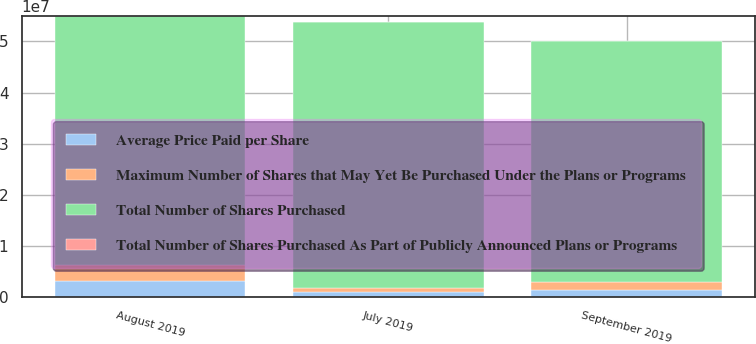<chart> <loc_0><loc_0><loc_500><loc_500><stacked_bar_chart><ecel><fcel>July 2019<fcel>August 2019<fcel>September 2019<nl><fcel>Average Price Paid per Share<fcel>971064<fcel>3.15705e+06<fcel>1.45965e+06<nl><fcel>Total Number of Shares Purchased As Part of Publicly Announced Plans or Programs<fcel>34.52<fcel>27.97<fcel>28.48<nl><fcel>Maximum Number of Shares that May Yet Be Purchased Under the Plans or Programs<fcel>971064<fcel>3.15705e+06<fcel>1.45965e+06<nl><fcel>Total Number of Shares Purchased<fcel>5.17925e+07<fcel>4.86355e+07<fcel>4.71758e+07<nl></chart> 